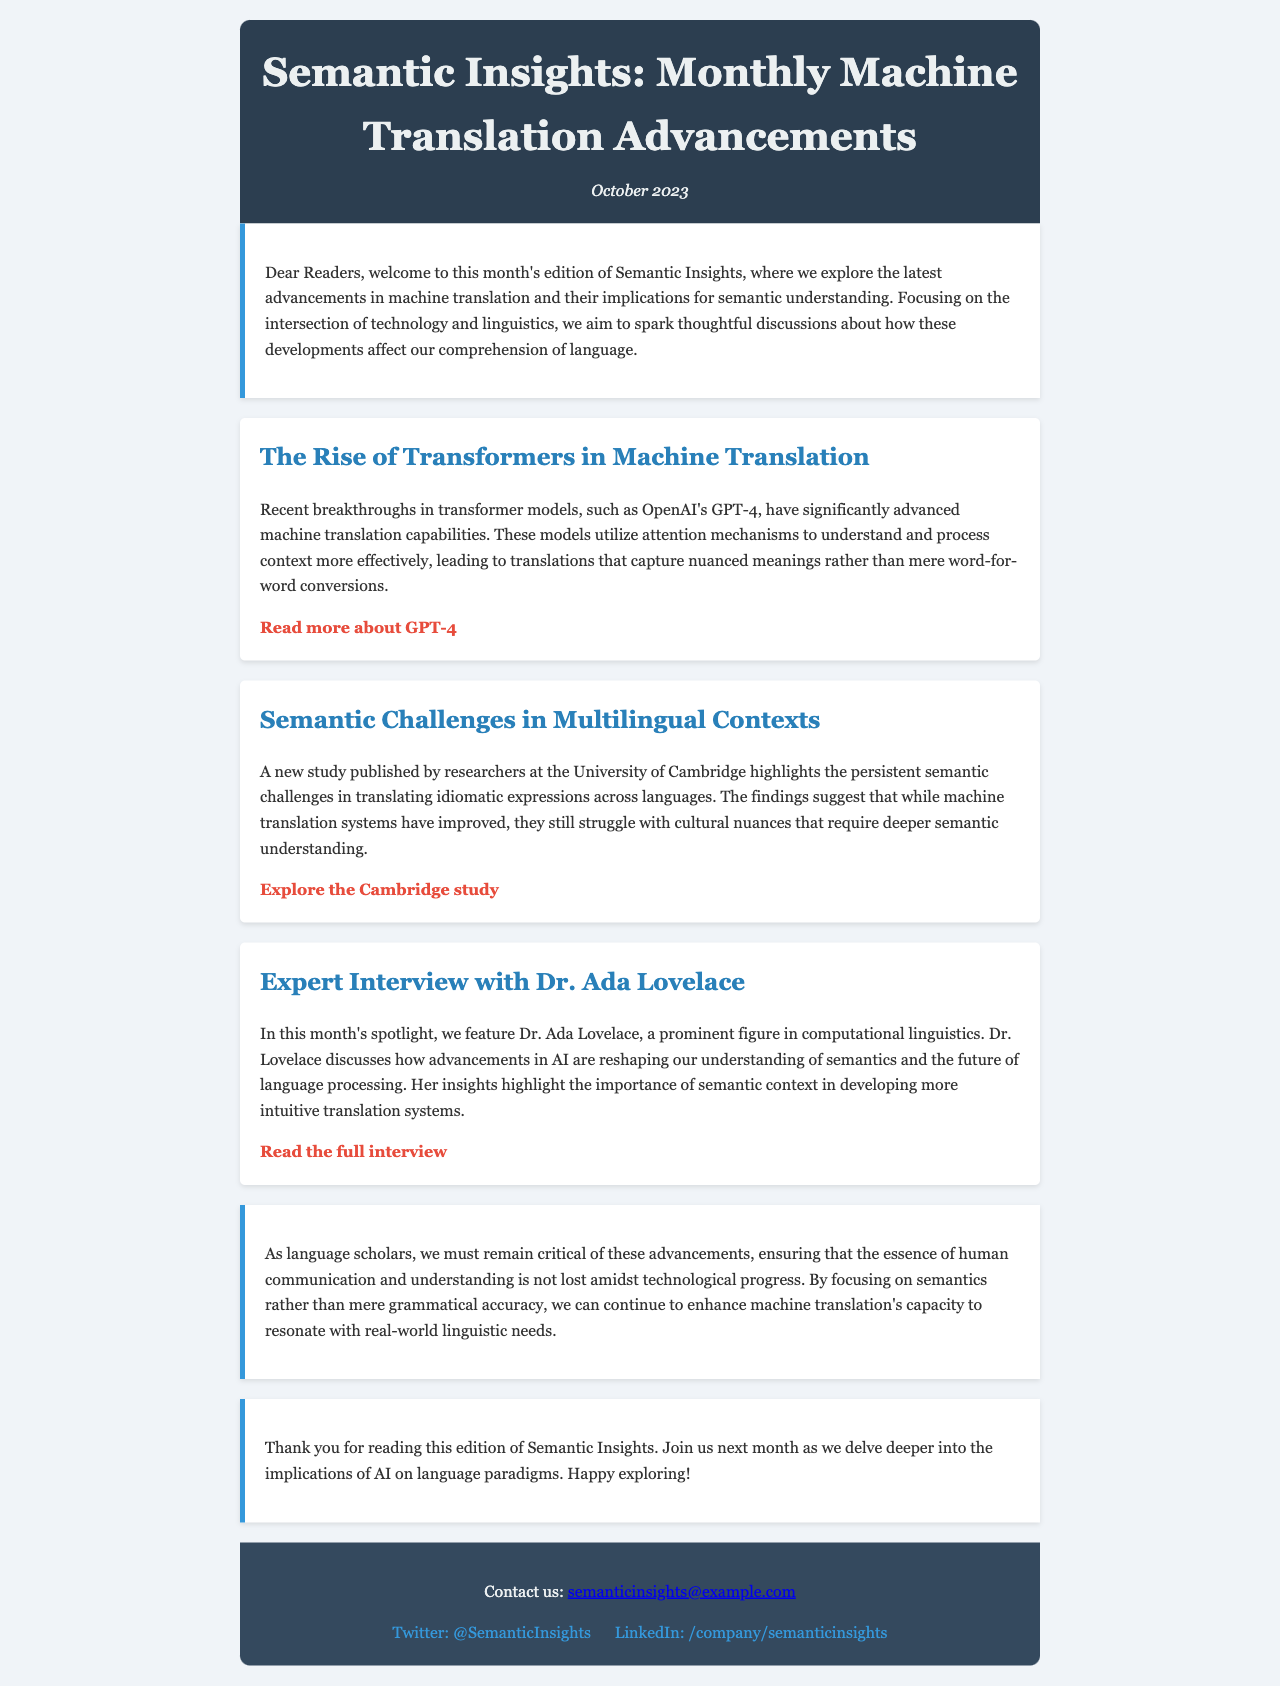what is the title of the newsletter? The title of the newsletter is provided in the header of the document.
Answer: Semantic Insights: Monthly Machine Translation Advancements what date is mentioned for this edition? The date is indicated below the title in the header section.
Answer: October 2023 who is featured in the expert interview? The document introduces an expert featured in one of the articles.
Answer: Dr. Ada Lovelace what is the primary focus of the newsletter? The introduction explicitly states the goal and thematic focus of the newsletter.
Answer: Advancements in machine translation and their implications for semantic understanding what challenge in machine translation is highlighted by the University of Cambridge study? The document discusses specific semantic issues that arise in translation.
Answer: Cultural nuances which technology is mentioned as having significant advancements in machine translation? An article specifically highlights a particular model that has advanced machine translation.
Answer: Transformers what does Dr. Lovelace discuss regarding language processing? Dr. Lovelace's insights on linguistics and AI are summarized in the interview article.
Answer: Importance of semantic context what is the overarching caution advised to language scholars? The document emphasizes a critical stance on current advancements in machine translation.
Answer: Not to lose the essence of human communication how can readers contact the newsletter team? A contact method is listed in the footer section of the newsletter.
Answer: Email: semanticinsights@example.com 